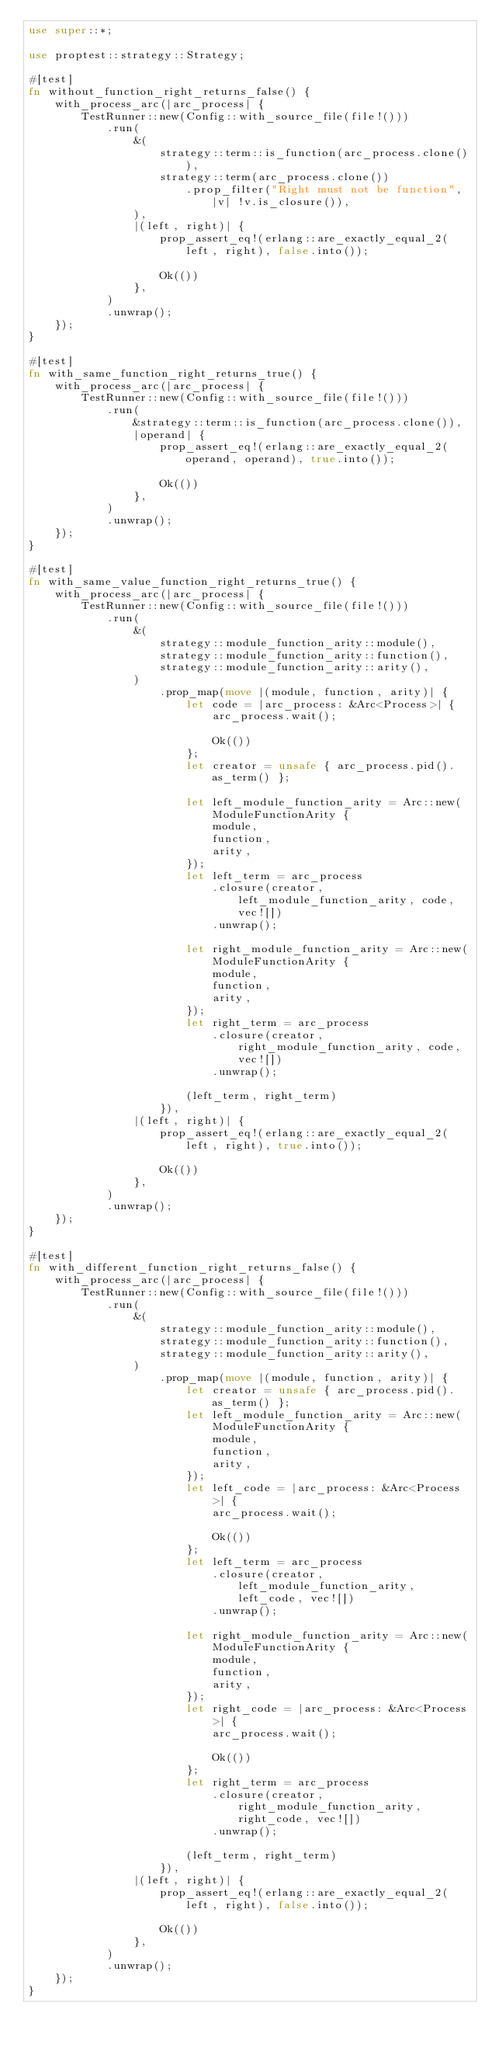<code> <loc_0><loc_0><loc_500><loc_500><_Rust_>use super::*;

use proptest::strategy::Strategy;

#[test]
fn without_function_right_returns_false() {
    with_process_arc(|arc_process| {
        TestRunner::new(Config::with_source_file(file!()))
            .run(
                &(
                    strategy::term::is_function(arc_process.clone()),
                    strategy::term(arc_process.clone())
                        .prop_filter("Right must not be function", |v| !v.is_closure()),
                ),
                |(left, right)| {
                    prop_assert_eq!(erlang::are_exactly_equal_2(left, right), false.into());

                    Ok(())
                },
            )
            .unwrap();
    });
}

#[test]
fn with_same_function_right_returns_true() {
    with_process_arc(|arc_process| {
        TestRunner::new(Config::with_source_file(file!()))
            .run(
                &strategy::term::is_function(arc_process.clone()),
                |operand| {
                    prop_assert_eq!(erlang::are_exactly_equal_2(operand, operand), true.into());

                    Ok(())
                },
            )
            .unwrap();
    });
}

#[test]
fn with_same_value_function_right_returns_true() {
    with_process_arc(|arc_process| {
        TestRunner::new(Config::with_source_file(file!()))
            .run(
                &(
                    strategy::module_function_arity::module(),
                    strategy::module_function_arity::function(),
                    strategy::module_function_arity::arity(),
                )
                    .prop_map(move |(module, function, arity)| {
                        let code = |arc_process: &Arc<Process>| {
                            arc_process.wait();

                            Ok(())
                        };
                        let creator = unsafe { arc_process.pid().as_term() };

                        let left_module_function_arity = Arc::new(ModuleFunctionArity {
                            module,
                            function,
                            arity,
                        });
                        let left_term = arc_process
                            .closure(creator, left_module_function_arity, code, vec![])
                            .unwrap();

                        let right_module_function_arity = Arc::new(ModuleFunctionArity {
                            module,
                            function,
                            arity,
                        });
                        let right_term = arc_process
                            .closure(creator, right_module_function_arity, code, vec![])
                            .unwrap();

                        (left_term, right_term)
                    }),
                |(left, right)| {
                    prop_assert_eq!(erlang::are_exactly_equal_2(left, right), true.into());

                    Ok(())
                },
            )
            .unwrap();
    });
}

#[test]
fn with_different_function_right_returns_false() {
    with_process_arc(|arc_process| {
        TestRunner::new(Config::with_source_file(file!()))
            .run(
                &(
                    strategy::module_function_arity::module(),
                    strategy::module_function_arity::function(),
                    strategy::module_function_arity::arity(),
                )
                    .prop_map(move |(module, function, arity)| {
                        let creator = unsafe { arc_process.pid().as_term() };
                        let left_module_function_arity = Arc::new(ModuleFunctionArity {
                            module,
                            function,
                            arity,
                        });
                        let left_code = |arc_process: &Arc<Process>| {
                            arc_process.wait();

                            Ok(())
                        };
                        let left_term = arc_process
                            .closure(creator, left_module_function_arity, left_code, vec![])
                            .unwrap();

                        let right_module_function_arity = Arc::new(ModuleFunctionArity {
                            module,
                            function,
                            arity,
                        });
                        let right_code = |arc_process: &Arc<Process>| {
                            arc_process.wait();

                            Ok(())
                        };
                        let right_term = arc_process
                            .closure(creator, right_module_function_arity, right_code, vec![])
                            .unwrap();

                        (left_term, right_term)
                    }),
                |(left, right)| {
                    prop_assert_eq!(erlang::are_exactly_equal_2(left, right), false.into());

                    Ok(())
                },
            )
            .unwrap();
    });
}
</code> 